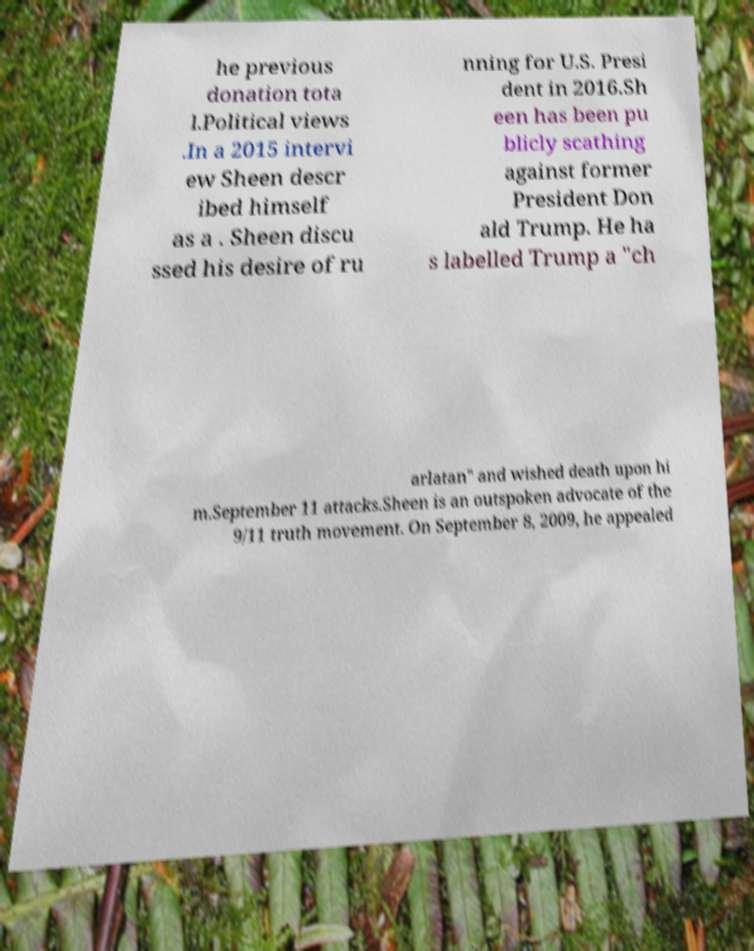Please read and relay the text visible in this image. What does it say? he previous donation tota l.Political views .In a 2015 intervi ew Sheen descr ibed himself as a . Sheen discu ssed his desire of ru nning for U.S. Presi dent in 2016.Sh een has been pu blicly scathing against former President Don ald Trump. He ha s labelled Trump a "ch arlatan" and wished death upon hi m.September 11 attacks.Sheen is an outspoken advocate of the 9/11 truth movement. On September 8, 2009, he appealed 